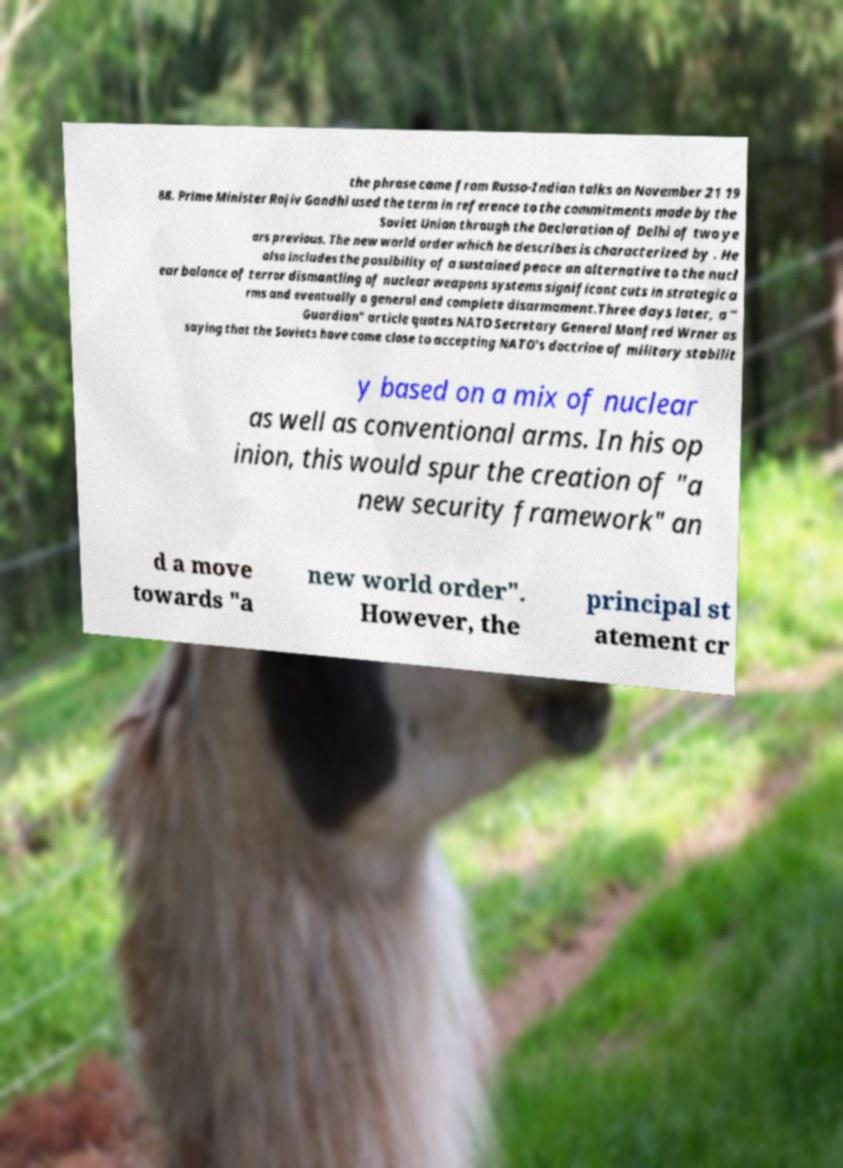Could you assist in decoding the text presented in this image and type it out clearly? the phrase came from Russo-Indian talks on November 21 19 88. Prime Minister Rajiv Gandhi used the term in reference to the commitments made by the Soviet Union through the Declaration of Delhi of two ye ars previous. The new world order which he describes is characterized by . He also includes the possibility of a sustained peace an alternative to the nucl ear balance of terror dismantling of nuclear weapons systems significant cuts in strategic a rms and eventually a general and complete disarmament.Three days later, a " Guardian" article quotes NATO Secretary General Manfred Wrner as saying that the Soviets have come close to accepting NATO's doctrine of military stabilit y based on a mix of nuclear as well as conventional arms. In his op inion, this would spur the creation of "a new security framework" an d a move towards "a new world order". However, the principal st atement cr 